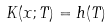<formula> <loc_0><loc_0><loc_500><loc_500>K ( x ; T ) = h ( T )</formula> 